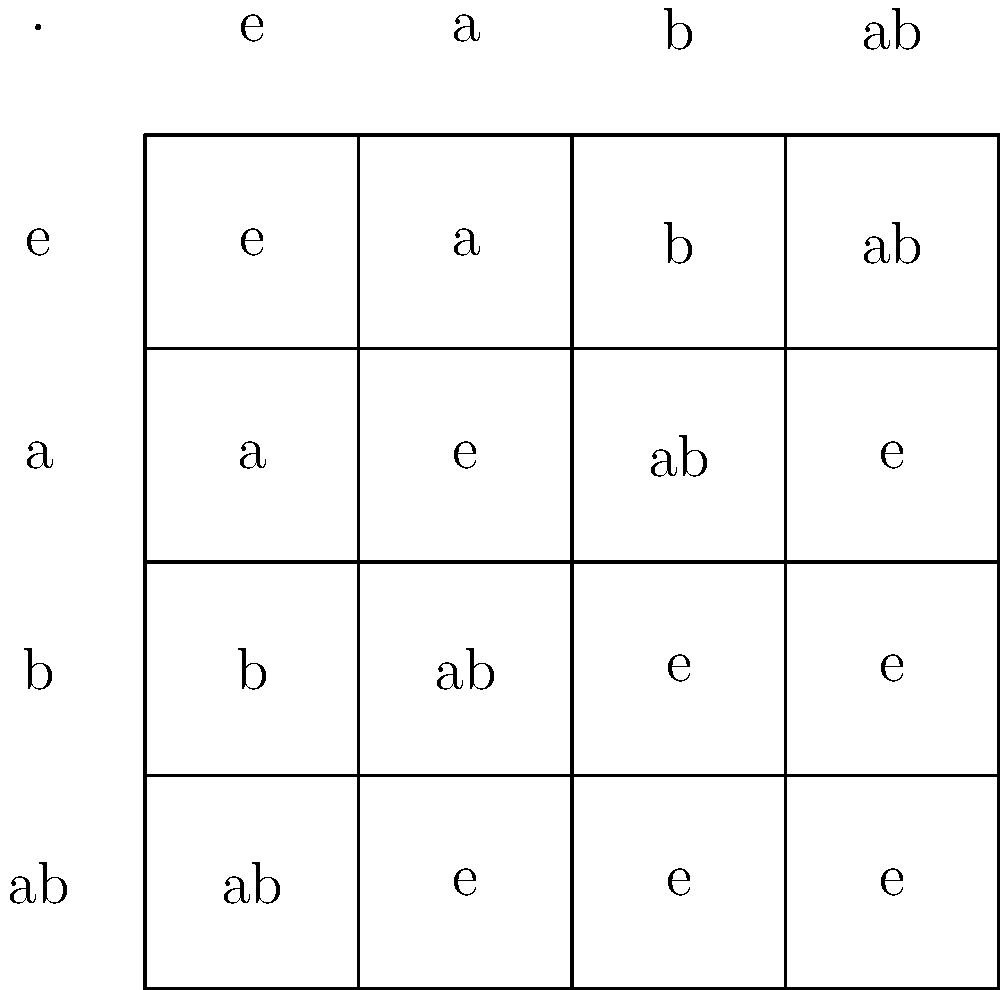Given the Cayley table for a group of order 4, identify all proper non-trivial subgroups and their orders. How does this information relate to Lagrange's theorem? To solve this problem, we'll follow these steps:

1. Analyze the Cayley table:
   The group elements are {e, a, b, ab}, where e is the identity element.

2. Identify proper non-trivial subgroups:
   a) {e, a}: Closed under multiplication, contains identity, and a^2 = e.
   b) {e, b}: Closed under multiplication, contains identity, and b^2 = e.

3. Determine the orders of the subgroups:
   Both {e, a} and {e, b} have order 2.

4. Relate to Lagrange's theorem:
   Lagrange's theorem states that the order of any subgroup must divide the order of the group.
   Group order: 4
   Subgroup orders: 2
   Indeed, 2 divides 4, confirming Lagrange's theorem.

5. Visualize subgroups in the Cayley table:
   The subgroups form smaller "sub-tables" within the main Cayley table.
   For {e, a}: Top-left 2x2 square
   For {e, b}: 2x2 square formed by e and b rows/columns

This visualization demonstrates how subgroups are self-contained within the larger group structure, reflecting their closure property and adherence to Lagrange's theorem.
Answer: Two subgroups of order 2: {e, a} and {e, b}. Confirms Lagrange's theorem: subgroup orders (2) divide group order (4). 